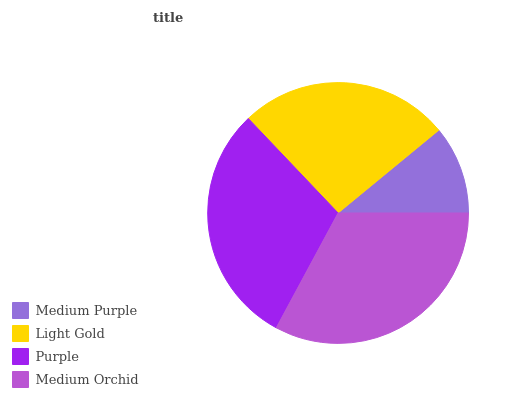Is Medium Purple the minimum?
Answer yes or no. Yes. Is Medium Orchid the maximum?
Answer yes or no. Yes. Is Light Gold the minimum?
Answer yes or no. No. Is Light Gold the maximum?
Answer yes or no. No. Is Light Gold greater than Medium Purple?
Answer yes or no. Yes. Is Medium Purple less than Light Gold?
Answer yes or no. Yes. Is Medium Purple greater than Light Gold?
Answer yes or no. No. Is Light Gold less than Medium Purple?
Answer yes or no. No. Is Purple the high median?
Answer yes or no. Yes. Is Light Gold the low median?
Answer yes or no. Yes. Is Medium Purple the high median?
Answer yes or no. No. Is Medium Purple the low median?
Answer yes or no. No. 